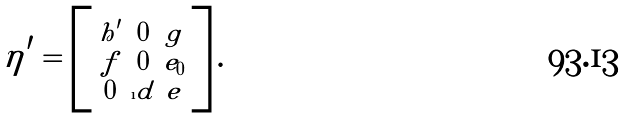<formula> <loc_0><loc_0><loc_500><loc_500>\eta ^ { \prime } = \left [ \begin{smallmatrix} h ^ { \prime } & 0 & g \\ f & 0 & e _ { 0 } \\ 0 & \i d & e \end{smallmatrix} \right ] .</formula> 